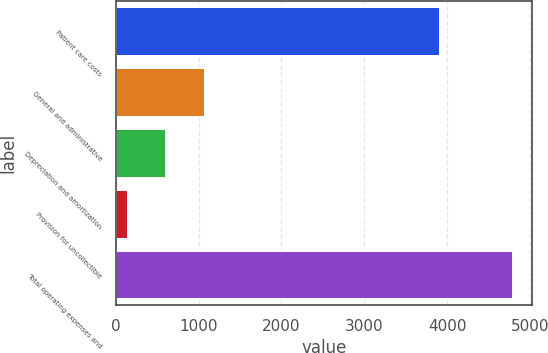Convert chart. <chart><loc_0><loc_0><loc_500><loc_500><bar_chart><fcel>Patient care costs<fcel>General and administrative<fcel>Depreciation and amortization<fcel>Provision for uncollectible<fcel>Total operating expenses and<nl><fcel>3920<fcel>1075<fcel>610.5<fcel>146<fcel>4791<nl></chart> 